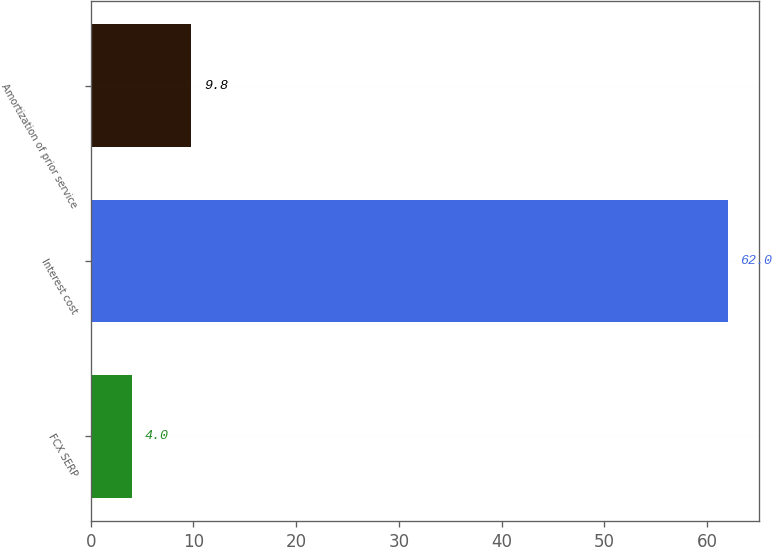Convert chart. <chart><loc_0><loc_0><loc_500><loc_500><bar_chart><fcel>FCX SERP<fcel>Interest cost<fcel>Amortization of prior service<nl><fcel>4<fcel>62<fcel>9.8<nl></chart> 